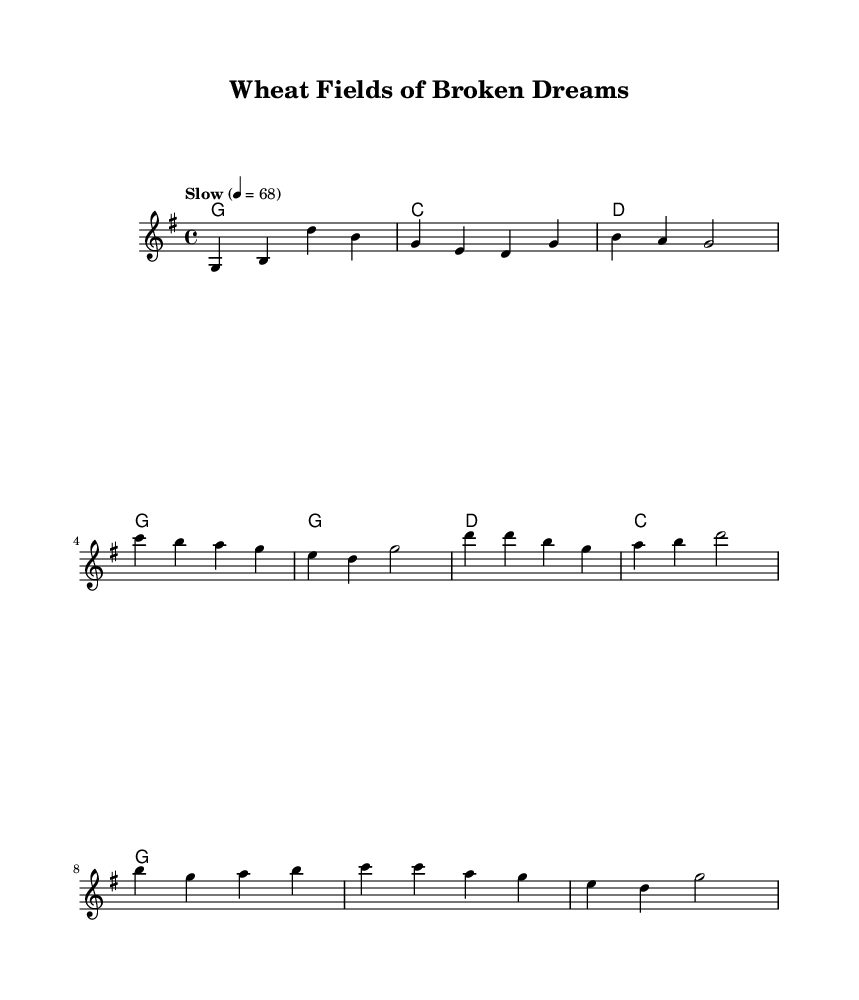What is the key signature of this music? The key signature indicates that the piece is in G major, which has one sharp (F#). This is found at the beginning of the staff where the key signature is notated.
Answer: G major What is the time signature of this music? The time signature is presented after the key signature at the beginning of the music. It shows that there are four beats in each measure, represented by the 4/4 time signature.
Answer: 4/4 What is the tempo marking for this piece? The tempo marking is indicated by the text next to the tempo symbol at the start of the score. The marking says "Slow" with a specific beat of quarter note = 68, indicating a relaxed pace.
Answer: Slow 4 = 68 How many lines are in the melody section? The melody section in this score is written on a standard staff, which comprises five lines. Counting them gives a total of five lines for the melody.
Answer: 5 What is the title of this piece? The title can be found at the top of the sheet music before the first line of the score. It clearly states "Wheat Fields of Broken Dreams."
Answer: Wheat Fields of Broken Dreams Which section contains the lyric "In the wheat fields of broken dreams"? This specific lyric is part of the chorus, which is distinctly separated from the verse section. It is labeled as "chorus" in the lyrics section of the score.
Answer: Chorus What is the arrangement of the harmonies for the verse? The arrangement of harmonies for the verse is provided in a chord format following the melody. It consists of the chords G, C, D, and G repeated for each line of the verse.
Answer: G, C, D, G 